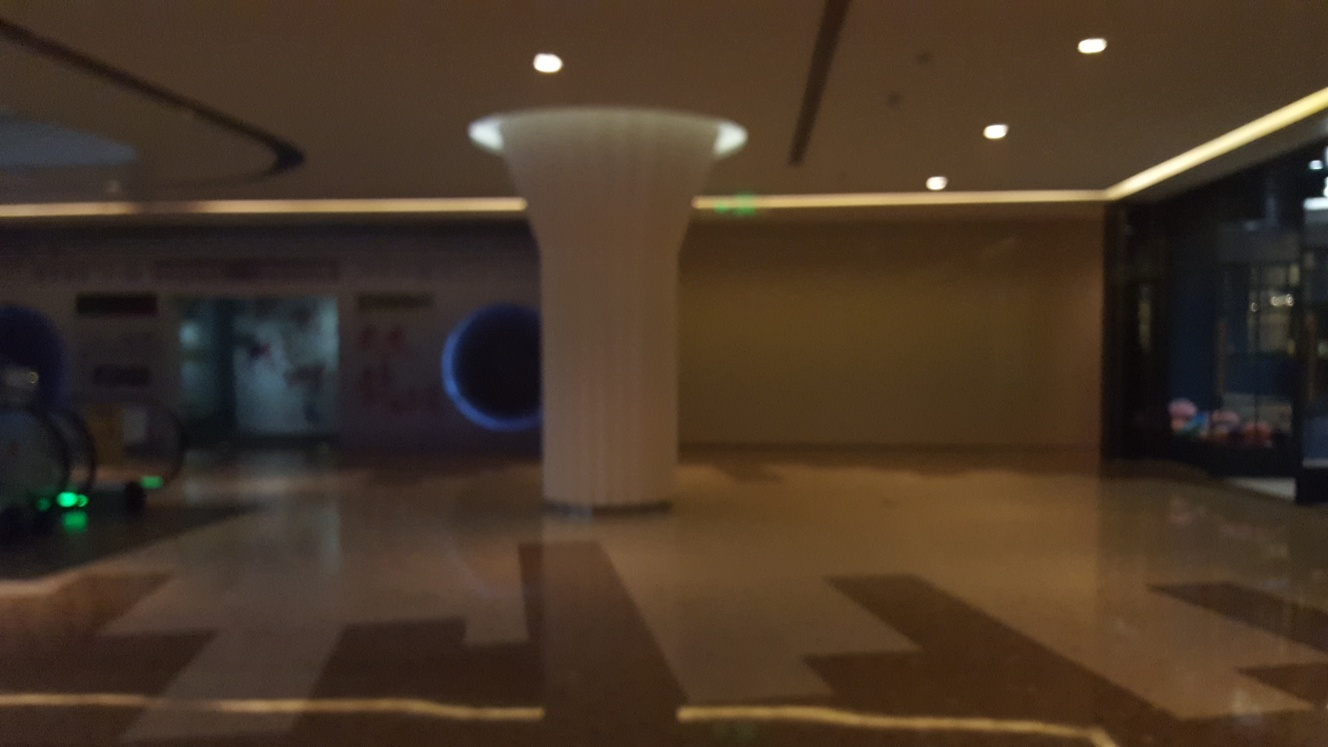Can you describe the lighting in this space? The lighting appears subdued and ambient, with soft illumination emanating from above. There are no harsh shadows, suggesting a gentle and diffused light source, likely designed to create a calming atmosphere within the space. 